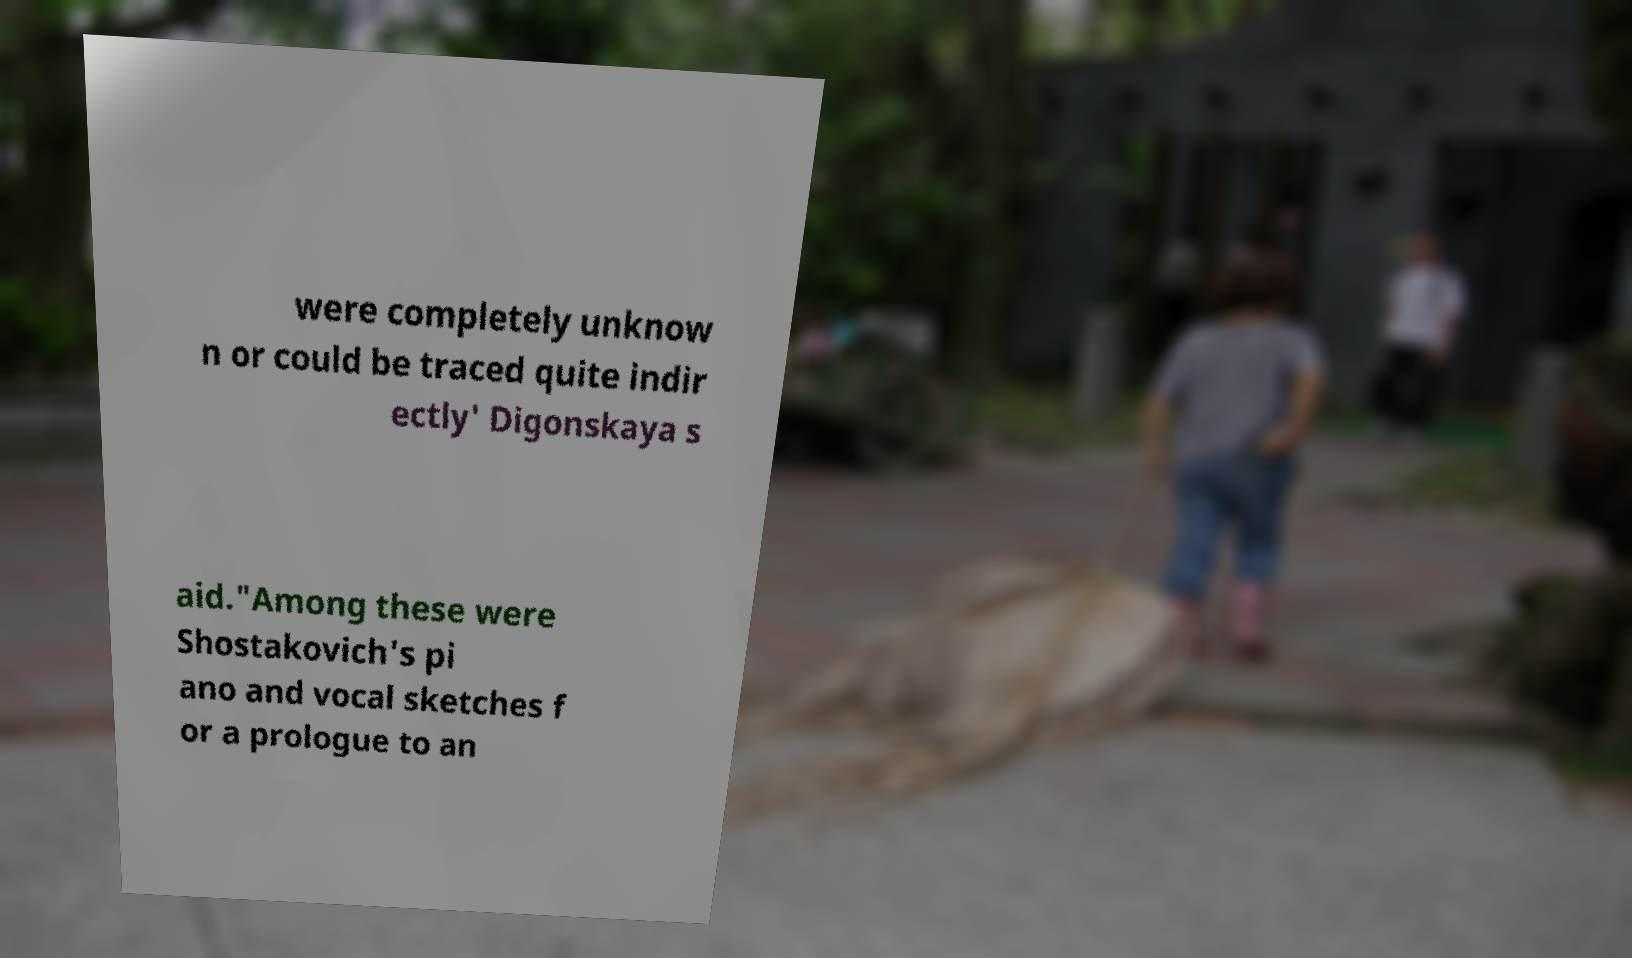Please identify and transcribe the text found in this image. were completely unknow n or could be traced quite indir ectly' Digonskaya s aid."Among these were Shostakovich's pi ano and vocal sketches f or a prologue to an 